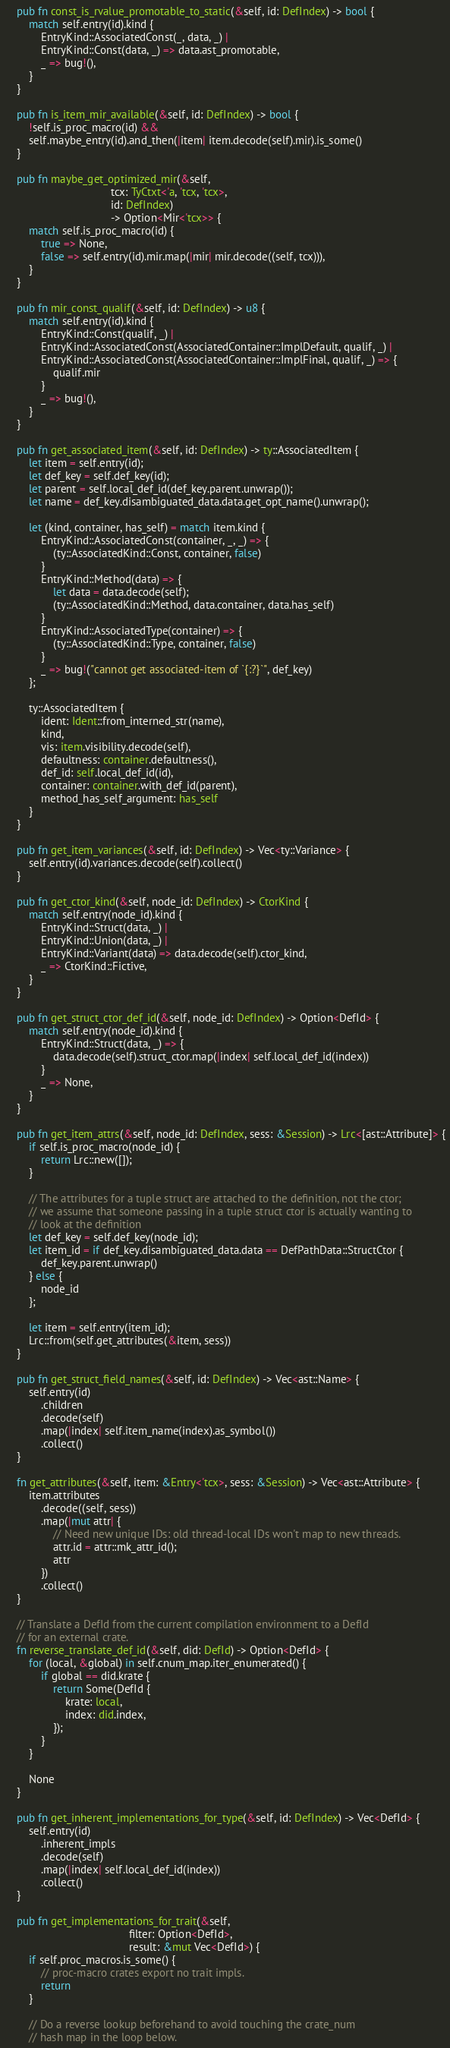Convert code to text. <code><loc_0><loc_0><loc_500><loc_500><_Rust_>    pub fn const_is_rvalue_promotable_to_static(&self, id: DefIndex) -> bool {
        match self.entry(id).kind {
            EntryKind::AssociatedConst(_, data, _) |
            EntryKind::Const(data, _) => data.ast_promotable,
            _ => bug!(),
        }
    }

    pub fn is_item_mir_available(&self, id: DefIndex) -> bool {
        !self.is_proc_macro(id) &&
        self.maybe_entry(id).and_then(|item| item.decode(self).mir).is_some()
    }

    pub fn maybe_get_optimized_mir(&self,
                                   tcx: TyCtxt<'a, 'tcx, 'tcx>,
                                   id: DefIndex)
                                   -> Option<Mir<'tcx>> {
        match self.is_proc_macro(id) {
            true => None,
            false => self.entry(id).mir.map(|mir| mir.decode((self, tcx))),
        }
    }

    pub fn mir_const_qualif(&self, id: DefIndex) -> u8 {
        match self.entry(id).kind {
            EntryKind::Const(qualif, _) |
            EntryKind::AssociatedConst(AssociatedContainer::ImplDefault, qualif, _) |
            EntryKind::AssociatedConst(AssociatedContainer::ImplFinal, qualif, _) => {
                qualif.mir
            }
            _ => bug!(),
        }
    }

    pub fn get_associated_item(&self, id: DefIndex) -> ty::AssociatedItem {
        let item = self.entry(id);
        let def_key = self.def_key(id);
        let parent = self.local_def_id(def_key.parent.unwrap());
        let name = def_key.disambiguated_data.data.get_opt_name().unwrap();

        let (kind, container, has_self) = match item.kind {
            EntryKind::AssociatedConst(container, _, _) => {
                (ty::AssociatedKind::Const, container, false)
            }
            EntryKind::Method(data) => {
                let data = data.decode(self);
                (ty::AssociatedKind::Method, data.container, data.has_self)
            }
            EntryKind::AssociatedType(container) => {
                (ty::AssociatedKind::Type, container, false)
            }
            _ => bug!("cannot get associated-item of `{:?}`", def_key)
        };

        ty::AssociatedItem {
            ident: Ident::from_interned_str(name),
            kind,
            vis: item.visibility.decode(self),
            defaultness: container.defaultness(),
            def_id: self.local_def_id(id),
            container: container.with_def_id(parent),
            method_has_self_argument: has_self
        }
    }

    pub fn get_item_variances(&self, id: DefIndex) -> Vec<ty::Variance> {
        self.entry(id).variances.decode(self).collect()
    }

    pub fn get_ctor_kind(&self, node_id: DefIndex) -> CtorKind {
        match self.entry(node_id).kind {
            EntryKind::Struct(data, _) |
            EntryKind::Union(data, _) |
            EntryKind::Variant(data) => data.decode(self).ctor_kind,
            _ => CtorKind::Fictive,
        }
    }

    pub fn get_struct_ctor_def_id(&self, node_id: DefIndex) -> Option<DefId> {
        match self.entry(node_id).kind {
            EntryKind::Struct(data, _) => {
                data.decode(self).struct_ctor.map(|index| self.local_def_id(index))
            }
            _ => None,
        }
    }

    pub fn get_item_attrs(&self, node_id: DefIndex, sess: &Session) -> Lrc<[ast::Attribute]> {
        if self.is_proc_macro(node_id) {
            return Lrc::new([]);
        }

        // The attributes for a tuple struct are attached to the definition, not the ctor;
        // we assume that someone passing in a tuple struct ctor is actually wanting to
        // look at the definition
        let def_key = self.def_key(node_id);
        let item_id = if def_key.disambiguated_data.data == DefPathData::StructCtor {
            def_key.parent.unwrap()
        } else {
            node_id
        };

        let item = self.entry(item_id);
        Lrc::from(self.get_attributes(&item, sess))
    }

    pub fn get_struct_field_names(&self, id: DefIndex) -> Vec<ast::Name> {
        self.entry(id)
            .children
            .decode(self)
            .map(|index| self.item_name(index).as_symbol())
            .collect()
    }

    fn get_attributes(&self, item: &Entry<'tcx>, sess: &Session) -> Vec<ast::Attribute> {
        item.attributes
            .decode((self, sess))
            .map(|mut attr| {
                // Need new unique IDs: old thread-local IDs won't map to new threads.
                attr.id = attr::mk_attr_id();
                attr
            })
            .collect()
    }

    // Translate a DefId from the current compilation environment to a DefId
    // for an external crate.
    fn reverse_translate_def_id(&self, did: DefId) -> Option<DefId> {
        for (local, &global) in self.cnum_map.iter_enumerated() {
            if global == did.krate {
                return Some(DefId {
                    krate: local,
                    index: did.index,
                });
            }
        }

        None
    }

    pub fn get_inherent_implementations_for_type(&self, id: DefIndex) -> Vec<DefId> {
        self.entry(id)
            .inherent_impls
            .decode(self)
            .map(|index| self.local_def_id(index))
            .collect()
    }

    pub fn get_implementations_for_trait(&self,
                                         filter: Option<DefId>,
                                         result: &mut Vec<DefId>) {
        if self.proc_macros.is_some() {
            // proc-macro crates export no trait impls.
            return
        }

        // Do a reverse lookup beforehand to avoid touching the crate_num
        // hash map in the loop below.</code> 